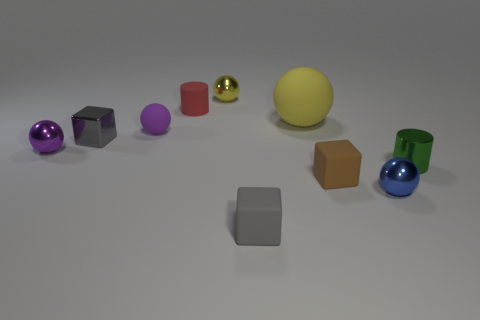Subtract all blue spheres. How many spheres are left? 4 Subtract all blocks. How many objects are left? 7 Add 1 purple rubber objects. How many purple rubber objects exist? 2 Subtract 0 blue blocks. How many objects are left? 10 Subtract all large green cylinders. Subtract all small gray objects. How many objects are left? 8 Add 6 small blue shiny balls. How many small blue shiny balls are left? 7 